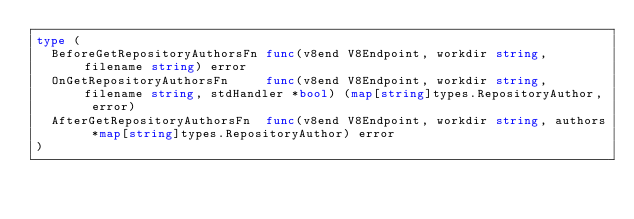<code> <loc_0><loc_0><loc_500><loc_500><_Go_>type (
	BeforeGetRepositoryAuthorsFn func(v8end V8Endpoint, workdir string, filename string) error
	OnGetRepositoryAuthorsFn     func(v8end V8Endpoint, workdir string, filename string, stdHandler *bool) (map[string]types.RepositoryAuthor, error)
	AfterGetRepositoryAuthorsFn  func(v8end V8Endpoint, workdir string, authors *map[string]types.RepositoryAuthor) error
)
</code> 